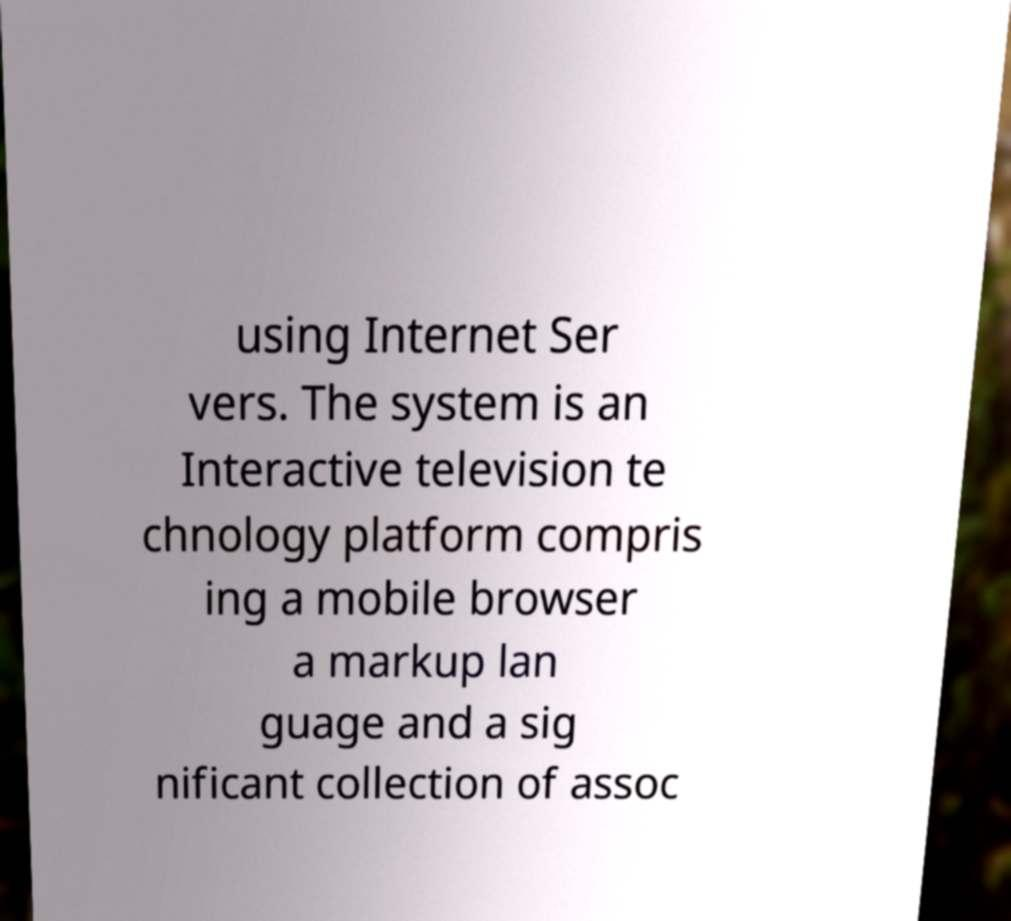There's text embedded in this image that I need extracted. Can you transcribe it verbatim? using Internet Ser vers. The system is an Interactive television te chnology platform compris ing a mobile browser a markup lan guage and a sig nificant collection of assoc 